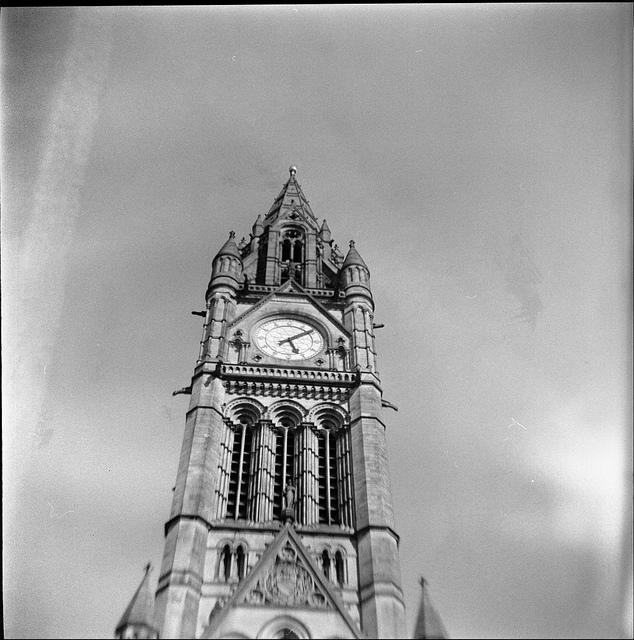How many banana stems without bananas are there?
Give a very brief answer. 0. 